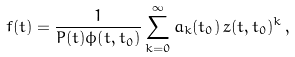Convert formula to latex. <formula><loc_0><loc_0><loc_500><loc_500>f ( t ) = \frac { 1 } { P ( t ) \phi ( t , t _ { 0 } ) } \sum _ { k = 0 } ^ { \infty } a _ { k } ( t _ { 0 } ) \, z ( t , t _ { 0 } ) ^ { k } \, ,</formula> 